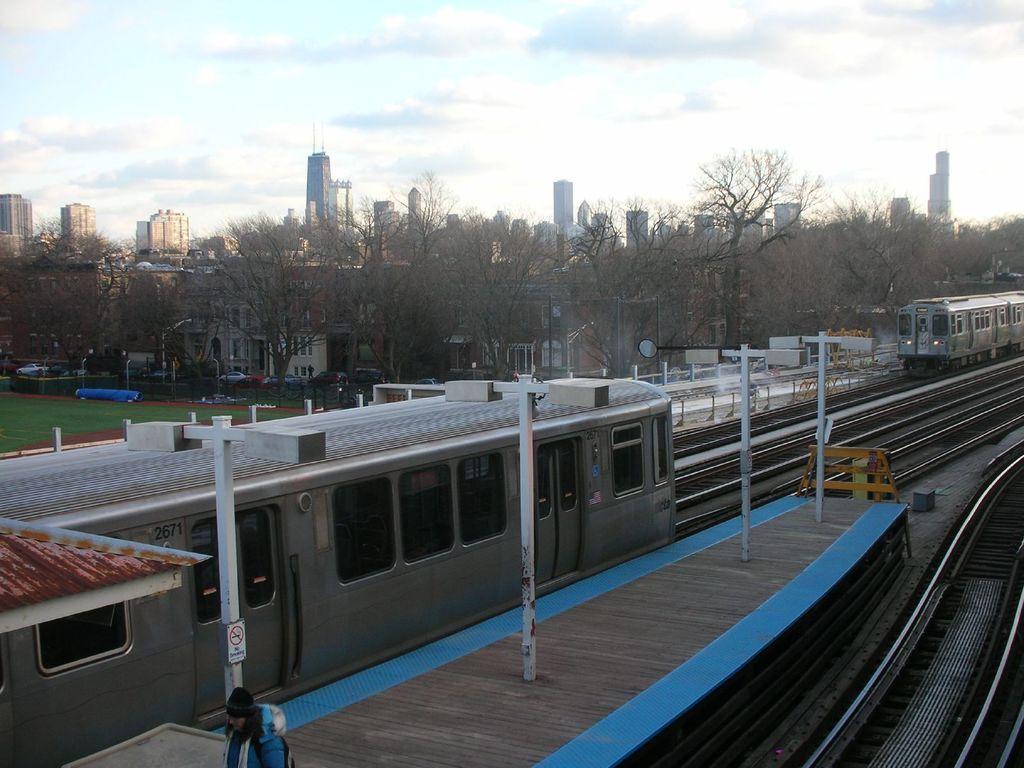Could you give a brief overview of what you see in this image? In this picture we can see few trains on a railway track. There is a signboard on the pole. We can see a barricade on the path. There is a person on bottom left. Some grass on the ground is visible. There are few trees, street lights, vehicles on the road and some buildings in the background. Sky is cloudy. 